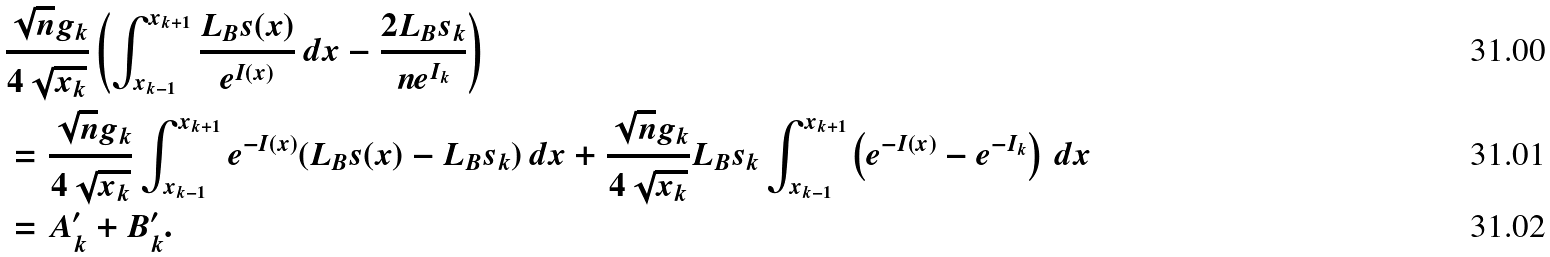Convert formula to latex. <formula><loc_0><loc_0><loc_500><loc_500>& \frac { \sqrt { n } g _ { k } } { 4 \sqrt { x _ { k } } } \left ( \int _ { x _ { k - 1 } } ^ { x _ { k + 1 } } \frac { L _ { B } s ( x ) } { e ^ { I ( x ) } } \, d x - \frac { 2 L _ { B } s _ { k } } { n e ^ { I _ { k } } } \right ) \\ & = \frac { \sqrt { n } g _ { k } } { 4 \sqrt { x _ { k } } } \int _ { x _ { k - 1 } } ^ { x _ { k + 1 } } e ^ { - I ( x ) } ( L _ { B } s ( x ) - L _ { B } s _ { k } ) \, d x + \frac { \sqrt { n } g _ { k } } { 4 \sqrt { x _ { k } } } L _ { B } s _ { k } \int _ { x _ { k - 1 } } ^ { x _ { k + 1 } } \left ( e ^ { - I ( x ) } - e ^ { - I _ { k } } \right ) \, d x \\ & = A ^ { \prime } _ { k } + B ^ { \prime } _ { k } .</formula> 